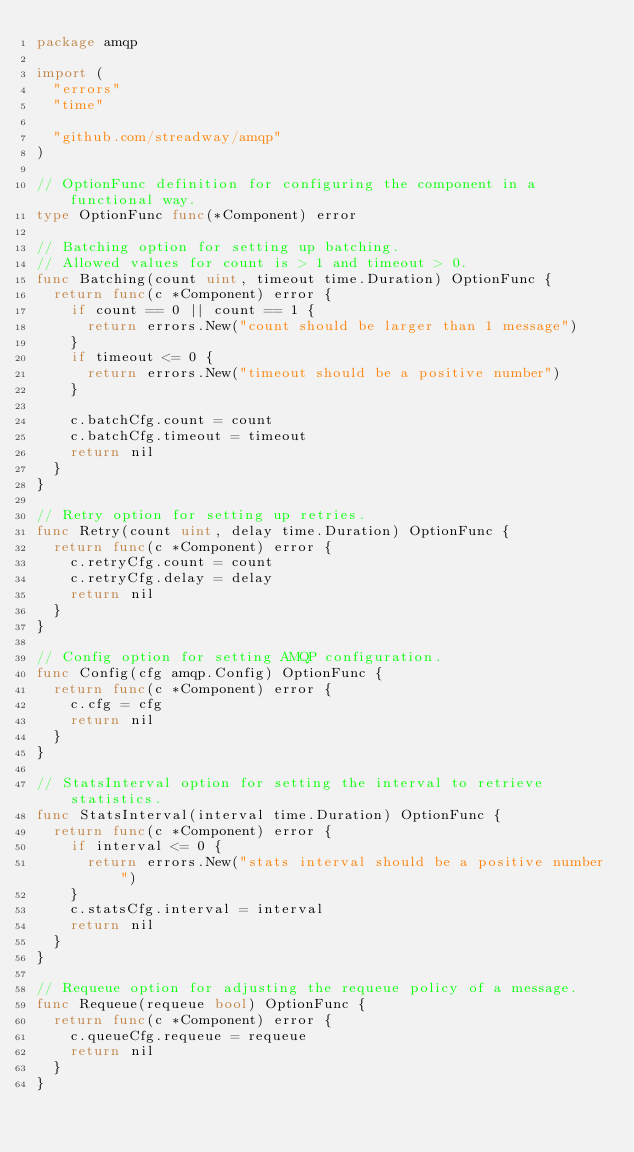<code> <loc_0><loc_0><loc_500><loc_500><_Go_>package amqp

import (
	"errors"
	"time"

	"github.com/streadway/amqp"
)

// OptionFunc definition for configuring the component in a functional way.
type OptionFunc func(*Component) error

// Batching option for setting up batching.
// Allowed values for count is > 1 and timeout > 0.
func Batching(count uint, timeout time.Duration) OptionFunc {
	return func(c *Component) error {
		if count == 0 || count == 1 {
			return errors.New("count should be larger than 1 message")
		}
		if timeout <= 0 {
			return errors.New("timeout should be a positive number")
		}

		c.batchCfg.count = count
		c.batchCfg.timeout = timeout
		return nil
	}
}

// Retry option for setting up retries.
func Retry(count uint, delay time.Duration) OptionFunc {
	return func(c *Component) error {
		c.retryCfg.count = count
		c.retryCfg.delay = delay
		return nil
	}
}

// Config option for setting AMQP configuration.
func Config(cfg amqp.Config) OptionFunc {
	return func(c *Component) error {
		c.cfg = cfg
		return nil
	}
}

// StatsInterval option for setting the interval to retrieve statistics.
func StatsInterval(interval time.Duration) OptionFunc {
	return func(c *Component) error {
		if interval <= 0 {
			return errors.New("stats interval should be a positive number")
		}
		c.statsCfg.interval = interval
		return nil
	}
}

// Requeue option for adjusting the requeue policy of a message.
func Requeue(requeue bool) OptionFunc {
	return func(c *Component) error {
		c.queueCfg.requeue = requeue
		return nil
	}
}
</code> 